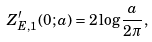Convert formula to latex. <formula><loc_0><loc_0><loc_500><loc_500>Z _ { E , 1 } ^ { \prime } ( 0 ; a ) = 2 \log \frac { a } { 2 \pi } ,</formula> 